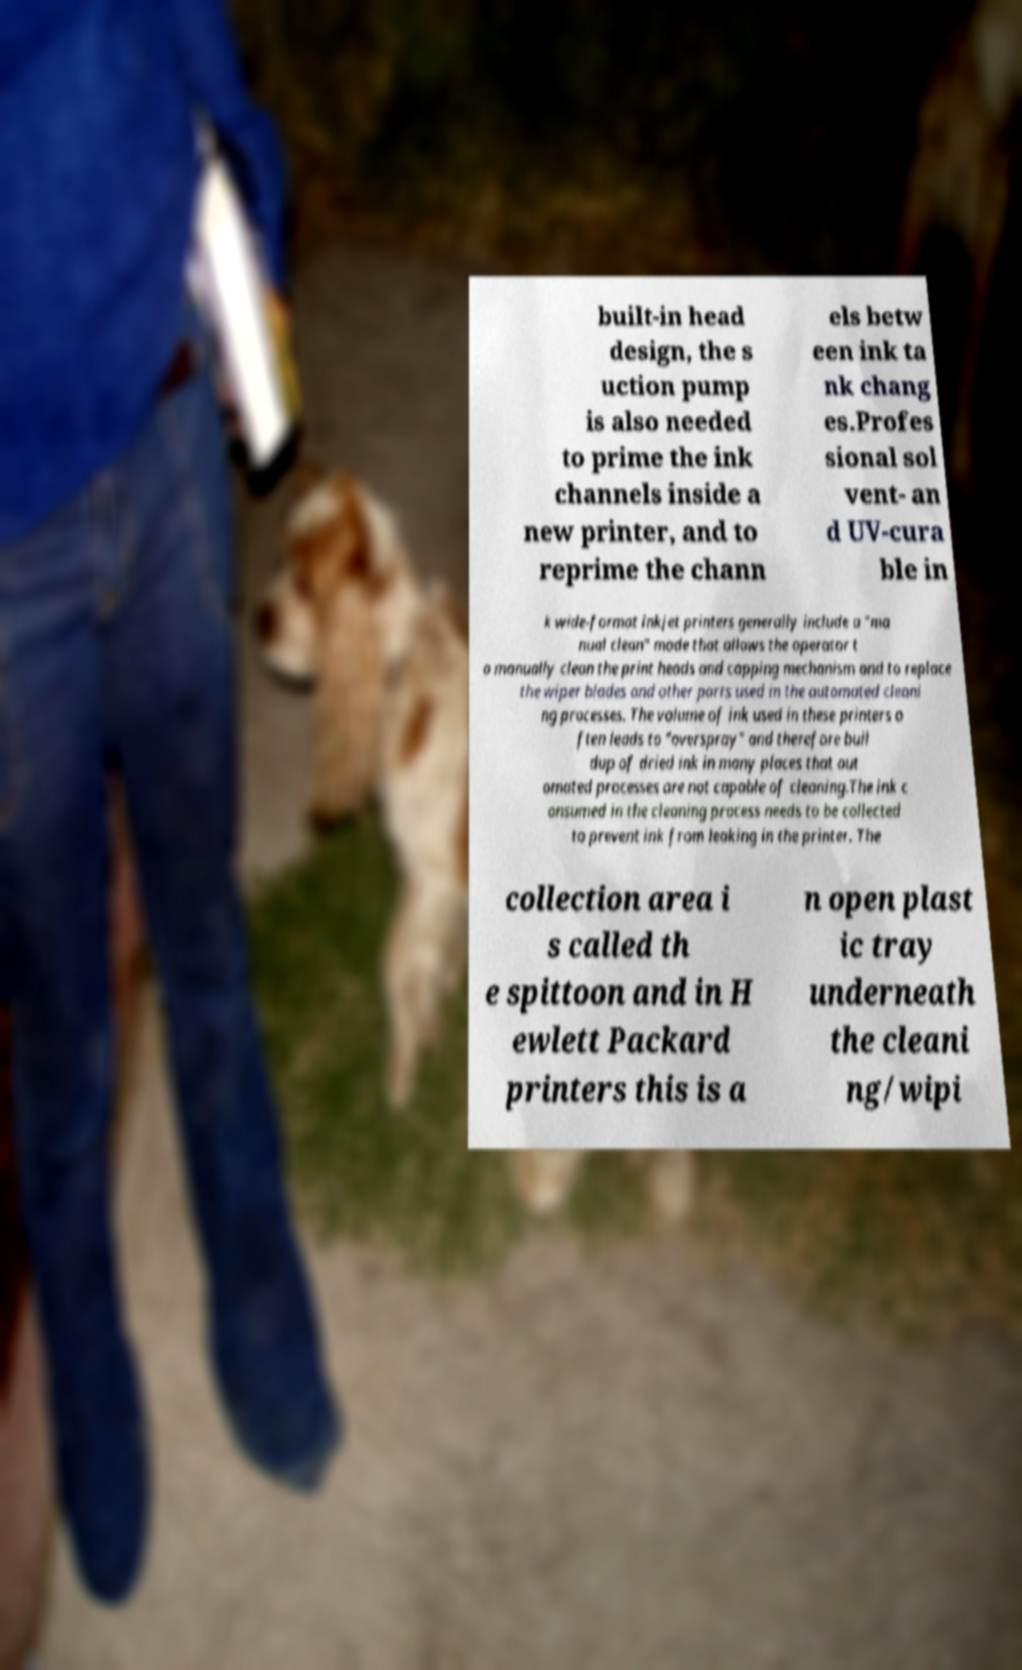Can you read and provide the text displayed in the image?This photo seems to have some interesting text. Can you extract and type it out for me? built-in head design, the s uction pump is also needed to prime the ink channels inside a new printer, and to reprime the chann els betw een ink ta nk chang es.Profes sional sol vent- an d UV-cura ble in k wide-format inkjet printers generally include a "ma nual clean" mode that allows the operator t o manually clean the print heads and capping mechanism and to replace the wiper blades and other parts used in the automated cleani ng processes. The volume of ink used in these printers o ften leads to "overspray" and therefore buil dup of dried ink in many places that aut omated processes are not capable of cleaning.The ink c onsumed in the cleaning process needs to be collected to prevent ink from leaking in the printer. The collection area i s called th e spittoon and in H ewlett Packard printers this is a n open plast ic tray underneath the cleani ng/wipi 